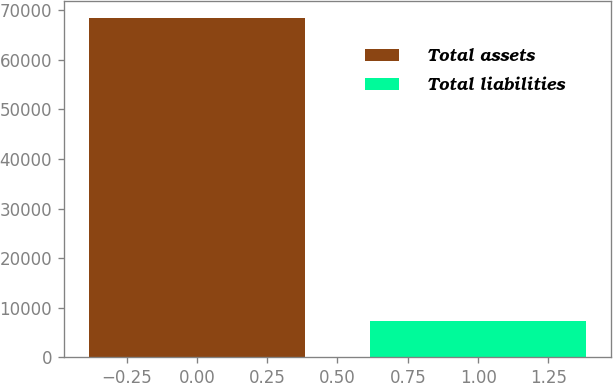Convert chart to OTSL. <chart><loc_0><loc_0><loc_500><loc_500><bar_chart><fcel>Total assets<fcel>Total liabilities<nl><fcel>68352<fcel>7356<nl></chart> 